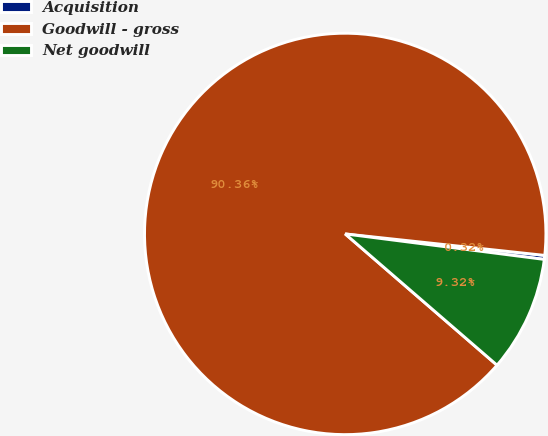Convert chart to OTSL. <chart><loc_0><loc_0><loc_500><loc_500><pie_chart><fcel>Acquisition<fcel>Goodwill - gross<fcel>Net goodwill<nl><fcel>0.32%<fcel>90.36%<fcel>9.32%<nl></chart> 